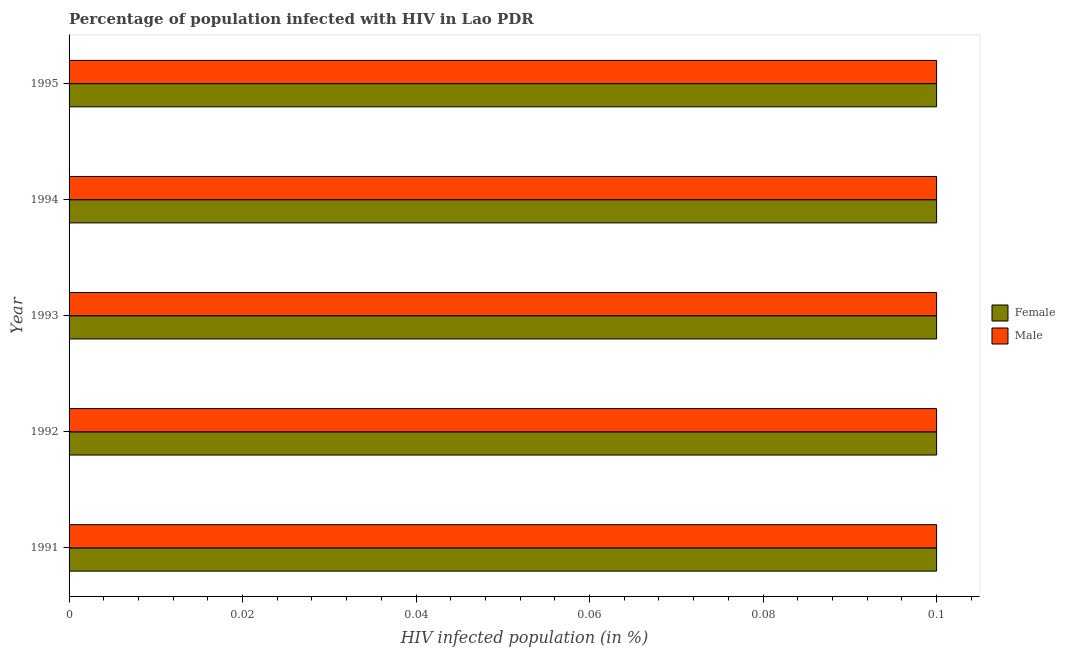How many groups of bars are there?
Ensure brevity in your answer.  5. Are the number of bars per tick equal to the number of legend labels?
Offer a terse response. Yes. What is the label of the 4th group of bars from the top?
Your answer should be very brief. 1992. What is the percentage of females who are infected with hiv in 1995?
Your response must be concise. 0.1. In which year was the percentage of males who are infected with hiv maximum?
Make the answer very short. 1991. What is the total percentage of females who are infected with hiv in the graph?
Offer a very short reply. 0.5. What is the ratio of the percentage of females who are infected with hiv in 1993 to that in 1995?
Give a very brief answer. 1. Is the percentage of males who are infected with hiv in 1992 less than that in 1995?
Your answer should be compact. No. What is the difference between the highest and the second highest percentage of males who are infected with hiv?
Your answer should be compact. 0. What does the 1st bar from the top in 1991 represents?
Offer a terse response. Male. What does the 2nd bar from the bottom in 1994 represents?
Offer a very short reply. Male. What is the difference between two consecutive major ticks on the X-axis?
Keep it short and to the point. 0.02. Does the graph contain any zero values?
Keep it short and to the point. No. How many legend labels are there?
Your answer should be compact. 2. What is the title of the graph?
Ensure brevity in your answer.  Percentage of population infected with HIV in Lao PDR. What is the label or title of the X-axis?
Your response must be concise. HIV infected population (in %). What is the HIV infected population (in %) in Male in 1991?
Make the answer very short. 0.1. What is the HIV infected population (in %) in Female in 1992?
Your answer should be compact. 0.1. What is the HIV infected population (in %) in Female in 1993?
Your answer should be compact. 0.1. What is the HIV infected population (in %) of Female in 1994?
Offer a terse response. 0.1. What is the HIV infected population (in %) in Male in 1995?
Make the answer very short. 0.1. Across all years, what is the minimum HIV infected population (in %) of Female?
Keep it short and to the point. 0.1. Across all years, what is the minimum HIV infected population (in %) of Male?
Keep it short and to the point. 0.1. What is the total HIV infected population (in %) in Female in the graph?
Ensure brevity in your answer.  0.5. What is the difference between the HIV infected population (in %) in Male in 1991 and that in 1992?
Offer a very short reply. 0. What is the difference between the HIV infected population (in %) in Female in 1991 and that in 1994?
Ensure brevity in your answer.  0. What is the difference between the HIV infected population (in %) in Male in 1992 and that in 1994?
Provide a short and direct response. 0. What is the difference between the HIV infected population (in %) of Female in 1993 and that in 1994?
Your answer should be compact. 0. What is the difference between the HIV infected population (in %) in Male in 1994 and that in 1995?
Make the answer very short. 0. What is the difference between the HIV infected population (in %) in Female in 1991 and the HIV infected population (in %) in Male in 1992?
Keep it short and to the point. 0. What is the difference between the HIV infected population (in %) of Female in 1991 and the HIV infected population (in %) of Male in 1993?
Ensure brevity in your answer.  0. What is the difference between the HIV infected population (in %) in Female in 1991 and the HIV infected population (in %) in Male in 1995?
Offer a terse response. 0. What is the difference between the HIV infected population (in %) in Female in 1992 and the HIV infected population (in %) in Male in 1994?
Keep it short and to the point. 0. What is the difference between the HIV infected population (in %) in Female in 1992 and the HIV infected population (in %) in Male in 1995?
Make the answer very short. 0. What is the difference between the HIV infected population (in %) in Female in 1993 and the HIV infected population (in %) in Male in 1994?
Give a very brief answer. 0. What is the difference between the HIV infected population (in %) of Female in 1993 and the HIV infected population (in %) of Male in 1995?
Keep it short and to the point. 0. What is the average HIV infected population (in %) of Male per year?
Give a very brief answer. 0.1. In the year 1992, what is the difference between the HIV infected population (in %) of Female and HIV infected population (in %) of Male?
Your response must be concise. 0. In the year 1995, what is the difference between the HIV infected population (in %) of Female and HIV infected population (in %) of Male?
Provide a short and direct response. 0. What is the ratio of the HIV infected population (in %) of Female in 1991 to that in 1992?
Your answer should be very brief. 1. What is the ratio of the HIV infected population (in %) of Female in 1991 to that in 1993?
Make the answer very short. 1. What is the ratio of the HIV infected population (in %) of Male in 1991 to that in 1993?
Keep it short and to the point. 1. What is the ratio of the HIV infected population (in %) of Female in 1991 to that in 1994?
Your answer should be compact. 1. What is the ratio of the HIV infected population (in %) of Male in 1991 to that in 1995?
Your response must be concise. 1. What is the ratio of the HIV infected population (in %) of Female in 1992 to that in 1994?
Your answer should be very brief. 1. What is the ratio of the HIV infected population (in %) of Male in 1992 to that in 1995?
Your response must be concise. 1. What is the ratio of the HIV infected population (in %) in Female in 1993 to that in 1994?
Provide a succinct answer. 1. What is the ratio of the HIV infected population (in %) in Male in 1993 to that in 1995?
Your answer should be compact. 1. What is the difference between the highest and the second highest HIV infected population (in %) of Female?
Provide a succinct answer. 0. 